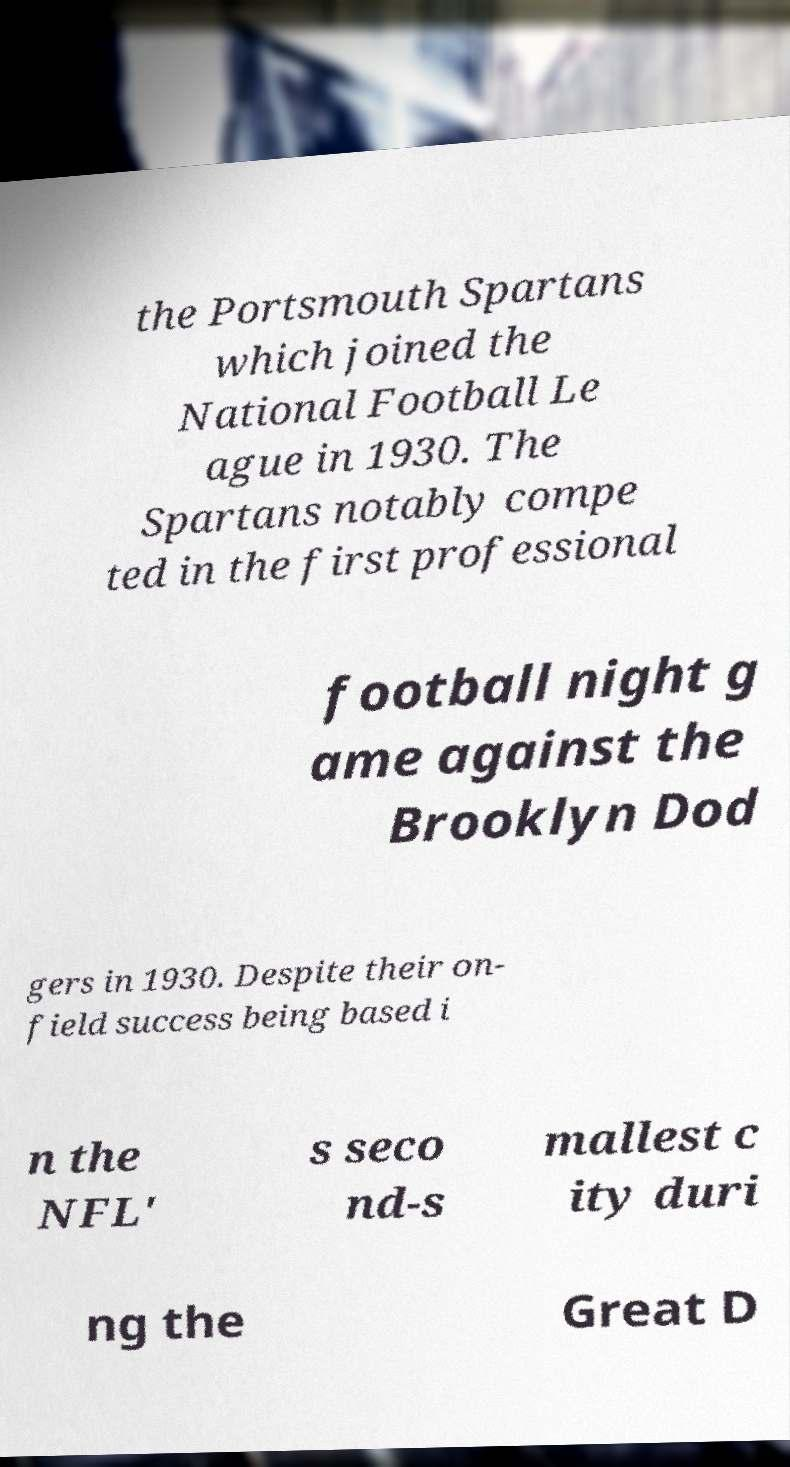Please identify and transcribe the text found in this image. the Portsmouth Spartans which joined the National Football Le ague in 1930. The Spartans notably compe ted in the first professional football night g ame against the Brooklyn Dod gers in 1930. Despite their on- field success being based i n the NFL' s seco nd-s mallest c ity duri ng the Great D 